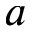<formula> <loc_0><loc_0><loc_500><loc_500>a</formula> 